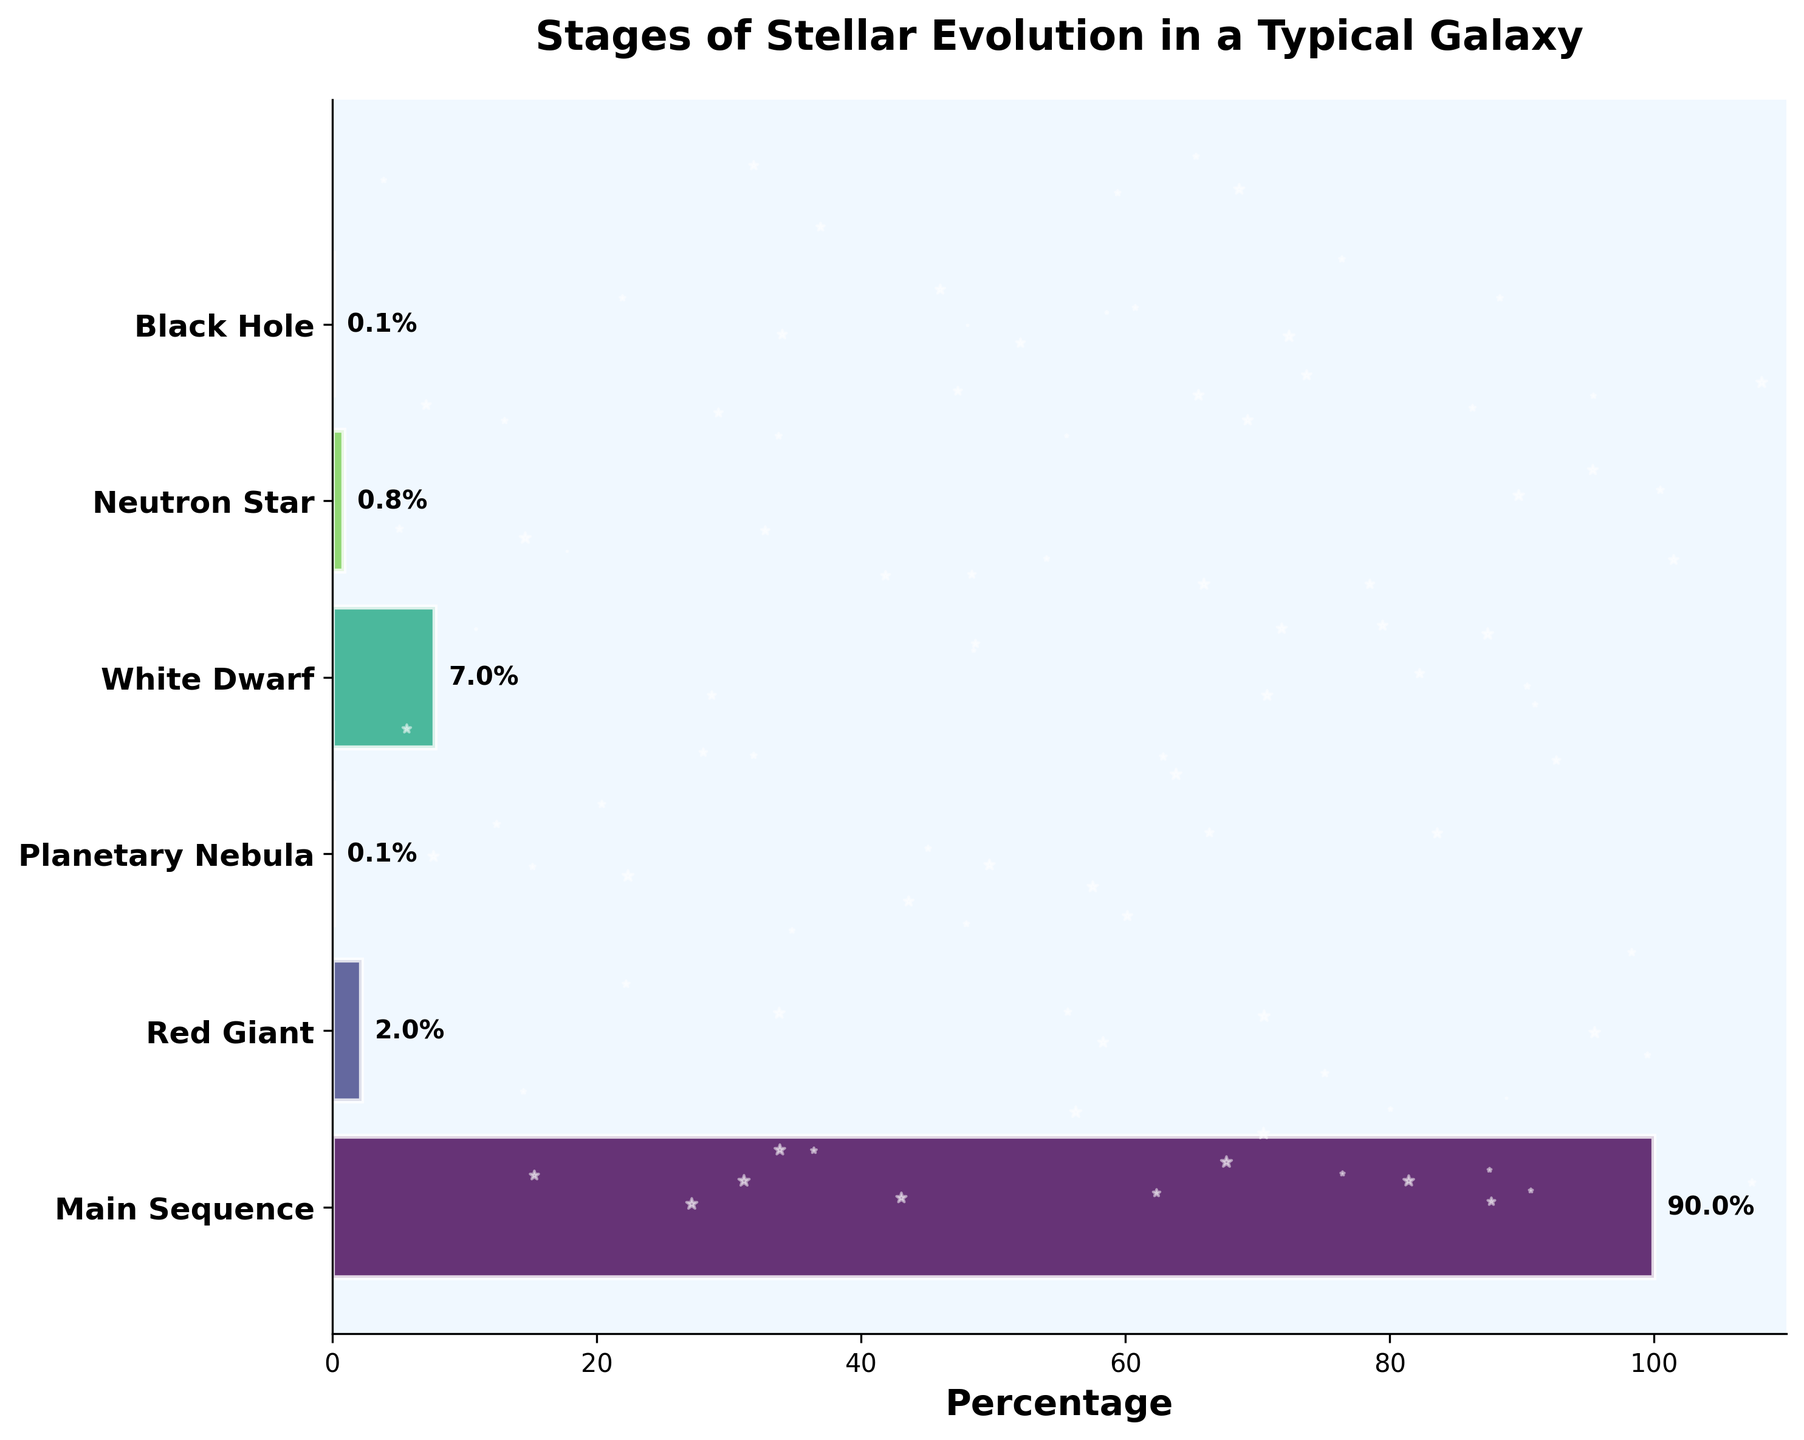Which stage has the highest percentage of stars? We look at the bar lengths to find the stage with the highest percentage. The "Main Sequence" bar is the longest and has a label reading 90%.
Answer: Main Sequence What is the percentage of stars that are in the White Dwarf stage? Locate the bar for the "White Dwarf" stage and read its label: it is 7%.
Answer: 7% How do the percentages of stars in the Red Giant and Neutron Star stages compare? Check the bars for "Red Giant" and "Neutron Star" stages and compare their labels. "Red Giant" is at 2%, while "Neutron Star" is at 0.8%.
Answer: Red Giant has a higher percentage What's the combined percentage of stars in the Red Giant and Planetary Nebula stages? Add the percentages of stars in "Red Giant" (2%) and "Planetary Nebula" (0.1%) stages: 2% + 0.1% = 2.1%.
Answer: 2.1% Is the percentage of stars in the Main Sequence stage greater or less than the percentage in all other stages combined? The percentage of stars in "Main Sequence" is 90%. Sum up percentages for all other stages: 2+0.1+7+0.8+0.1 = 10%. Since 90% is greater than 10%, the Main Sequence percentage is greater.
Answer: Greater How many stages are showcased in the funnel chart? Count the number of distinct stages listed on the y-axis. There are six stages: Main Sequence, Red Giant, Planetary Nebula, White Dwarf, Neutron Star, and Black Hole.
Answer: Six What is the difference in percentage between the White Dwarf and Black Hole stages? Subtract the percentage of stars in the "Black Hole" stage from that in the "White Dwarf" stage: 7% - 0.1% = 6.9%.
Answer: 6.9% What is the title of the funnel chart? Look at the text at the top of the chart. It reads "Stages of Stellar Evolution in a Typical Galaxy."
Answer: Stages of Stellar Evolution in a Typical Galaxy Which stages have a percentage of stars that is 1% or lower? Identify bars with labels showing percentages of 1% or less. "Planetary Nebula" (0.1%), "Neutron Star" (0.8%), and "Black Hole" (0.1%) fit this criterion.
Answer: Planetary Nebula, Neutron Star, Black Hole 